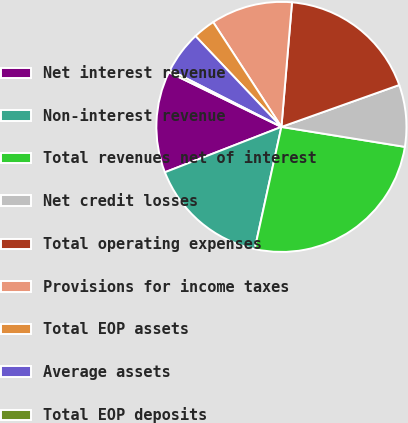<chart> <loc_0><loc_0><loc_500><loc_500><pie_chart><fcel>Net interest revenue<fcel>Non-interest revenue<fcel>Total revenues net of interest<fcel>Net credit losses<fcel>Total operating expenses<fcel>Provisions for income taxes<fcel>Total EOP assets<fcel>Average assets<fcel>Total EOP deposits<nl><fcel>13.1%<fcel>15.66%<fcel>25.88%<fcel>7.99%<fcel>18.21%<fcel>10.54%<fcel>2.87%<fcel>5.43%<fcel>0.32%<nl></chart> 